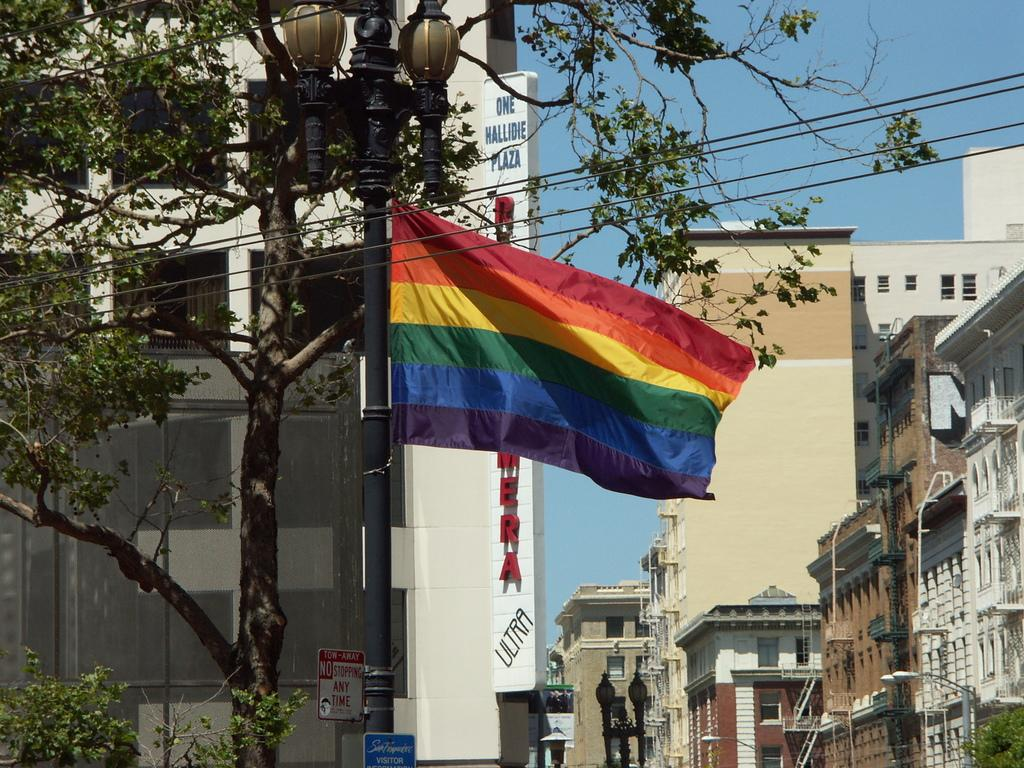What type of structures can be seen in the image? There are many buildings in the image. What else can be found on the street in the image? There is a street light pole in the image. What is attached to the street light pole? A multi-color flag is present on the street light pole. Are there any natural elements in the image? Yes, there is a tree in the image. What type of amusement park rides can be seen in the image? There are no amusement park rides present in the image. Can you see any spacecraft or astronauts in the image? No, there are no spacecraft or astronauts in the image. 